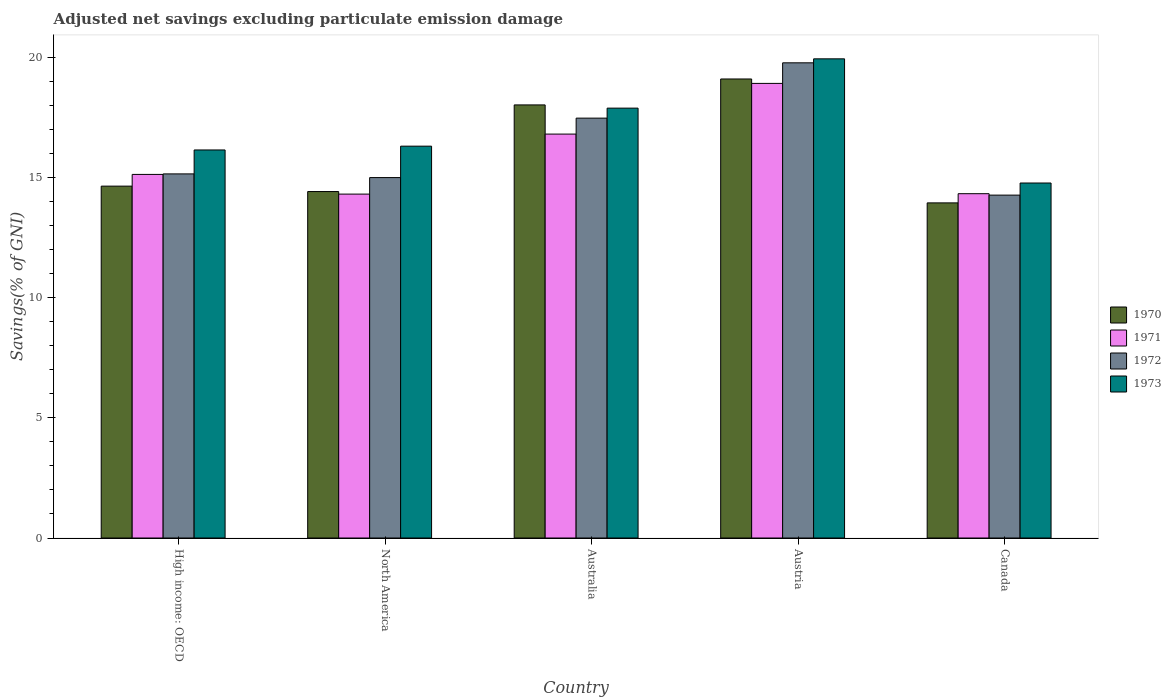Are the number of bars on each tick of the X-axis equal?
Your answer should be very brief. Yes. How many bars are there on the 1st tick from the right?
Keep it short and to the point. 4. What is the adjusted net savings in 1972 in North America?
Provide a short and direct response. 15. Across all countries, what is the maximum adjusted net savings in 1971?
Your answer should be compact. 18.92. Across all countries, what is the minimum adjusted net savings in 1970?
Offer a terse response. 13.95. In which country was the adjusted net savings in 1972 minimum?
Ensure brevity in your answer.  Canada. What is the total adjusted net savings in 1971 in the graph?
Your answer should be very brief. 79.51. What is the difference between the adjusted net savings in 1970 in Canada and that in High income: OECD?
Offer a terse response. -0.7. What is the difference between the adjusted net savings in 1973 in Canada and the adjusted net savings in 1972 in North America?
Make the answer very short. -0.23. What is the average adjusted net savings in 1970 per country?
Your answer should be compact. 16.03. What is the difference between the adjusted net savings of/in 1970 and adjusted net savings of/in 1972 in Australia?
Your answer should be very brief. 0.55. What is the ratio of the adjusted net savings in 1973 in High income: OECD to that in North America?
Give a very brief answer. 0.99. What is the difference between the highest and the second highest adjusted net savings in 1970?
Provide a short and direct response. -1.08. What is the difference between the highest and the lowest adjusted net savings in 1971?
Provide a succinct answer. 4.61. Is the sum of the adjusted net savings in 1972 in Austria and North America greater than the maximum adjusted net savings in 1971 across all countries?
Ensure brevity in your answer.  Yes. What does the 4th bar from the right in High income: OECD represents?
Offer a terse response. 1970. How many countries are there in the graph?
Ensure brevity in your answer.  5. Does the graph contain any zero values?
Offer a terse response. No. How many legend labels are there?
Make the answer very short. 4. How are the legend labels stacked?
Provide a short and direct response. Vertical. What is the title of the graph?
Your answer should be compact. Adjusted net savings excluding particulate emission damage. What is the label or title of the Y-axis?
Keep it short and to the point. Savings(% of GNI). What is the Savings(% of GNI) in 1970 in High income: OECD?
Offer a very short reply. 14.65. What is the Savings(% of GNI) of 1971 in High income: OECD?
Keep it short and to the point. 15.13. What is the Savings(% of GNI) in 1972 in High income: OECD?
Keep it short and to the point. 15.15. What is the Savings(% of GNI) in 1973 in High income: OECD?
Keep it short and to the point. 16.15. What is the Savings(% of GNI) in 1970 in North America?
Ensure brevity in your answer.  14.42. What is the Savings(% of GNI) in 1971 in North America?
Give a very brief answer. 14.31. What is the Savings(% of GNI) of 1972 in North America?
Make the answer very short. 15. What is the Savings(% of GNI) in 1973 in North America?
Your answer should be very brief. 16.31. What is the Savings(% of GNI) of 1970 in Australia?
Provide a succinct answer. 18.03. What is the Savings(% of GNI) in 1971 in Australia?
Give a very brief answer. 16.81. What is the Savings(% of GNI) of 1972 in Australia?
Offer a very short reply. 17.48. What is the Savings(% of GNI) of 1973 in Australia?
Your answer should be very brief. 17.89. What is the Savings(% of GNI) of 1970 in Austria?
Provide a succinct answer. 19.11. What is the Savings(% of GNI) of 1971 in Austria?
Your answer should be very brief. 18.92. What is the Savings(% of GNI) in 1972 in Austria?
Provide a succinct answer. 19.78. What is the Savings(% of GNI) in 1973 in Austria?
Ensure brevity in your answer.  19.94. What is the Savings(% of GNI) in 1970 in Canada?
Offer a very short reply. 13.95. What is the Savings(% of GNI) of 1971 in Canada?
Your answer should be very brief. 14.33. What is the Savings(% of GNI) in 1972 in Canada?
Ensure brevity in your answer.  14.27. What is the Savings(% of GNI) of 1973 in Canada?
Provide a short and direct response. 14.78. Across all countries, what is the maximum Savings(% of GNI) of 1970?
Keep it short and to the point. 19.11. Across all countries, what is the maximum Savings(% of GNI) of 1971?
Give a very brief answer. 18.92. Across all countries, what is the maximum Savings(% of GNI) in 1972?
Provide a short and direct response. 19.78. Across all countries, what is the maximum Savings(% of GNI) of 1973?
Provide a succinct answer. 19.94. Across all countries, what is the minimum Savings(% of GNI) in 1970?
Provide a succinct answer. 13.95. Across all countries, what is the minimum Savings(% of GNI) of 1971?
Your answer should be compact. 14.31. Across all countries, what is the minimum Savings(% of GNI) in 1972?
Make the answer very short. 14.27. Across all countries, what is the minimum Savings(% of GNI) in 1973?
Your answer should be very brief. 14.78. What is the total Savings(% of GNI) in 1970 in the graph?
Offer a very short reply. 80.15. What is the total Savings(% of GNI) in 1971 in the graph?
Offer a terse response. 79.51. What is the total Savings(% of GNI) of 1972 in the graph?
Provide a short and direct response. 81.68. What is the total Savings(% of GNI) of 1973 in the graph?
Provide a succinct answer. 85.07. What is the difference between the Savings(% of GNI) in 1970 in High income: OECD and that in North America?
Provide a succinct answer. 0.23. What is the difference between the Savings(% of GNI) of 1971 in High income: OECD and that in North America?
Your answer should be compact. 0.82. What is the difference between the Savings(% of GNI) of 1972 in High income: OECD and that in North America?
Make the answer very short. 0.15. What is the difference between the Savings(% of GNI) of 1973 in High income: OECD and that in North America?
Offer a very short reply. -0.16. What is the difference between the Savings(% of GNI) of 1970 in High income: OECD and that in Australia?
Offer a very short reply. -3.38. What is the difference between the Savings(% of GNI) in 1971 in High income: OECD and that in Australia?
Your answer should be very brief. -1.68. What is the difference between the Savings(% of GNI) of 1972 in High income: OECD and that in Australia?
Offer a terse response. -2.32. What is the difference between the Savings(% of GNI) in 1973 in High income: OECD and that in Australia?
Offer a very short reply. -1.74. What is the difference between the Savings(% of GNI) in 1970 in High income: OECD and that in Austria?
Give a very brief answer. -4.46. What is the difference between the Savings(% of GNI) in 1971 in High income: OECD and that in Austria?
Provide a succinct answer. -3.79. What is the difference between the Savings(% of GNI) of 1972 in High income: OECD and that in Austria?
Provide a short and direct response. -4.62. What is the difference between the Savings(% of GNI) in 1973 in High income: OECD and that in Austria?
Your response must be concise. -3.79. What is the difference between the Savings(% of GNI) in 1970 in High income: OECD and that in Canada?
Offer a very short reply. 0.7. What is the difference between the Savings(% of GNI) of 1971 in High income: OECD and that in Canada?
Offer a very short reply. 0.8. What is the difference between the Savings(% of GNI) of 1972 in High income: OECD and that in Canada?
Your response must be concise. 0.88. What is the difference between the Savings(% of GNI) in 1973 in High income: OECD and that in Canada?
Give a very brief answer. 1.38. What is the difference between the Savings(% of GNI) of 1970 in North America and that in Australia?
Ensure brevity in your answer.  -3.61. What is the difference between the Savings(% of GNI) of 1971 in North America and that in Australia?
Provide a succinct answer. -2.5. What is the difference between the Savings(% of GNI) of 1972 in North America and that in Australia?
Your answer should be very brief. -2.47. What is the difference between the Savings(% of GNI) of 1973 in North America and that in Australia?
Ensure brevity in your answer.  -1.58. What is the difference between the Savings(% of GNI) of 1970 in North America and that in Austria?
Provide a short and direct response. -4.69. What is the difference between the Savings(% of GNI) in 1971 in North America and that in Austria?
Provide a short and direct response. -4.61. What is the difference between the Savings(% of GNI) of 1972 in North America and that in Austria?
Make the answer very short. -4.78. What is the difference between the Savings(% of GNI) in 1973 in North America and that in Austria?
Your response must be concise. -3.63. What is the difference between the Savings(% of GNI) in 1970 in North America and that in Canada?
Make the answer very short. 0.47. What is the difference between the Savings(% of GNI) of 1971 in North America and that in Canada?
Ensure brevity in your answer.  -0.02. What is the difference between the Savings(% of GNI) of 1972 in North America and that in Canada?
Provide a short and direct response. 0.73. What is the difference between the Savings(% of GNI) of 1973 in North America and that in Canada?
Give a very brief answer. 1.53. What is the difference between the Savings(% of GNI) in 1970 in Australia and that in Austria?
Ensure brevity in your answer.  -1.08. What is the difference between the Savings(% of GNI) of 1971 in Australia and that in Austria?
Provide a succinct answer. -2.11. What is the difference between the Savings(% of GNI) of 1972 in Australia and that in Austria?
Ensure brevity in your answer.  -2.3. What is the difference between the Savings(% of GNI) in 1973 in Australia and that in Austria?
Your answer should be very brief. -2.05. What is the difference between the Savings(% of GNI) of 1970 in Australia and that in Canada?
Offer a very short reply. 4.08. What is the difference between the Savings(% of GNI) of 1971 in Australia and that in Canada?
Give a very brief answer. 2.48. What is the difference between the Savings(% of GNI) in 1972 in Australia and that in Canada?
Give a very brief answer. 3.2. What is the difference between the Savings(% of GNI) of 1973 in Australia and that in Canada?
Make the answer very short. 3.12. What is the difference between the Savings(% of GNI) of 1970 in Austria and that in Canada?
Offer a very short reply. 5.16. What is the difference between the Savings(% of GNI) in 1971 in Austria and that in Canada?
Your answer should be compact. 4.59. What is the difference between the Savings(% of GNI) in 1972 in Austria and that in Canada?
Give a very brief answer. 5.51. What is the difference between the Savings(% of GNI) in 1973 in Austria and that in Canada?
Your answer should be compact. 5.17. What is the difference between the Savings(% of GNI) in 1970 in High income: OECD and the Savings(% of GNI) in 1971 in North America?
Your answer should be very brief. 0.33. What is the difference between the Savings(% of GNI) in 1970 in High income: OECD and the Savings(% of GNI) in 1972 in North America?
Offer a very short reply. -0.36. What is the difference between the Savings(% of GNI) in 1970 in High income: OECD and the Savings(% of GNI) in 1973 in North America?
Provide a succinct answer. -1.66. What is the difference between the Savings(% of GNI) in 1971 in High income: OECD and the Savings(% of GNI) in 1972 in North America?
Your answer should be very brief. 0.13. What is the difference between the Savings(% of GNI) in 1971 in High income: OECD and the Savings(% of GNI) in 1973 in North America?
Your answer should be very brief. -1.18. What is the difference between the Savings(% of GNI) in 1972 in High income: OECD and the Savings(% of GNI) in 1973 in North America?
Your answer should be compact. -1.15. What is the difference between the Savings(% of GNI) in 1970 in High income: OECD and the Savings(% of GNI) in 1971 in Australia?
Offer a terse response. -2.17. What is the difference between the Savings(% of GNI) of 1970 in High income: OECD and the Savings(% of GNI) of 1972 in Australia?
Offer a very short reply. -2.83. What is the difference between the Savings(% of GNI) in 1970 in High income: OECD and the Savings(% of GNI) in 1973 in Australia?
Ensure brevity in your answer.  -3.25. What is the difference between the Savings(% of GNI) of 1971 in High income: OECD and the Savings(% of GNI) of 1972 in Australia?
Offer a very short reply. -2.34. What is the difference between the Savings(% of GNI) of 1971 in High income: OECD and the Savings(% of GNI) of 1973 in Australia?
Offer a terse response. -2.76. What is the difference between the Savings(% of GNI) in 1972 in High income: OECD and the Savings(% of GNI) in 1973 in Australia?
Your answer should be compact. -2.74. What is the difference between the Savings(% of GNI) in 1970 in High income: OECD and the Savings(% of GNI) in 1971 in Austria?
Make the answer very short. -4.28. What is the difference between the Savings(% of GNI) of 1970 in High income: OECD and the Savings(% of GNI) of 1972 in Austria?
Your response must be concise. -5.13. What is the difference between the Savings(% of GNI) in 1970 in High income: OECD and the Savings(% of GNI) in 1973 in Austria?
Your answer should be very brief. -5.3. What is the difference between the Savings(% of GNI) in 1971 in High income: OECD and the Savings(% of GNI) in 1972 in Austria?
Your answer should be compact. -4.64. What is the difference between the Savings(% of GNI) of 1971 in High income: OECD and the Savings(% of GNI) of 1973 in Austria?
Ensure brevity in your answer.  -4.81. What is the difference between the Savings(% of GNI) in 1972 in High income: OECD and the Savings(% of GNI) in 1973 in Austria?
Give a very brief answer. -4.79. What is the difference between the Savings(% of GNI) of 1970 in High income: OECD and the Savings(% of GNI) of 1971 in Canada?
Your answer should be very brief. 0.32. What is the difference between the Savings(% of GNI) in 1970 in High income: OECD and the Savings(% of GNI) in 1972 in Canada?
Keep it short and to the point. 0.37. What is the difference between the Savings(% of GNI) in 1970 in High income: OECD and the Savings(% of GNI) in 1973 in Canada?
Offer a terse response. -0.13. What is the difference between the Savings(% of GNI) in 1971 in High income: OECD and the Savings(% of GNI) in 1972 in Canada?
Ensure brevity in your answer.  0.86. What is the difference between the Savings(% of GNI) of 1971 in High income: OECD and the Savings(% of GNI) of 1973 in Canada?
Make the answer very short. 0.36. What is the difference between the Savings(% of GNI) in 1972 in High income: OECD and the Savings(% of GNI) in 1973 in Canada?
Provide a succinct answer. 0.38. What is the difference between the Savings(% of GNI) of 1970 in North America and the Savings(% of GNI) of 1971 in Australia?
Give a very brief answer. -2.39. What is the difference between the Savings(% of GNI) of 1970 in North America and the Savings(% of GNI) of 1972 in Australia?
Your answer should be very brief. -3.06. What is the difference between the Savings(% of GNI) of 1970 in North America and the Savings(% of GNI) of 1973 in Australia?
Keep it short and to the point. -3.47. What is the difference between the Savings(% of GNI) in 1971 in North America and the Savings(% of GNI) in 1972 in Australia?
Offer a terse response. -3.16. What is the difference between the Savings(% of GNI) in 1971 in North America and the Savings(% of GNI) in 1973 in Australia?
Provide a short and direct response. -3.58. What is the difference between the Savings(% of GNI) in 1972 in North America and the Savings(% of GNI) in 1973 in Australia?
Your response must be concise. -2.89. What is the difference between the Savings(% of GNI) of 1970 in North America and the Savings(% of GNI) of 1971 in Austria?
Make the answer very short. -4.5. What is the difference between the Savings(% of GNI) of 1970 in North America and the Savings(% of GNI) of 1972 in Austria?
Make the answer very short. -5.36. What is the difference between the Savings(% of GNI) in 1970 in North America and the Savings(% of GNI) in 1973 in Austria?
Offer a very short reply. -5.52. What is the difference between the Savings(% of GNI) of 1971 in North America and the Savings(% of GNI) of 1972 in Austria?
Make the answer very short. -5.46. What is the difference between the Savings(% of GNI) of 1971 in North America and the Savings(% of GNI) of 1973 in Austria?
Ensure brevity in your answer.  -5.63. What is the difference between the Savings(% of GNI) in 1972 in North America and the Savings(% of GNI) in 1973 in Austria?
Make the answer very short. -4.94. What is the difference between the Savings(% of GNI) in 1970 in North America and the Savings(% of GNI) in 1971 in Canada?
Offer a terse response. 0.09. What is the difference between the Savings(% of GNI) in 1970 in North America and the Savings(% of GNI) in 1972 in Canada?
Your answer should be compact. 0.15. What is the difference between the Savings(% of GNI) in 1970 in North America and the Savings(% of GNI) in 1973 in Canada?
Your answer should be compact. -0.36. What is the difference between the Savings(% of GNI) in 1971 in North America and the Savings(% of GNI) in 1972 in Canada?
Your response must be concise. 0.04. What is the difference between the Savings(% of GNI) of 1971 in North America and the Savings(% of GNI) of 1973 in Canada?
Offer a very short reply. -0.46. What is the difference between the Savings(% of GNI) in 1972 in North America and the Savings(% of GNI) in 1973 in Canada?
Provide a short and direct response. 0.23. What is the difference between the Savings(% of GNI) in 1970 in Australia and the Savings(% of GNI) in 1971 in Austria?
Offer a very short reply. -0.9. What is the difference between the Savings(% of GNI) of 1970 in Australia and the Savings(% of GNI) of 1972 in Austria?
Make the answer very short. -1.75. What is the difference between the Savings(% of GNI) of 1970 in Australia and the Savings(% of GNI) of 1973 in Austria?
Your answer should be very brief. -1.92. What is the difference between the Savings(% of GNI) of 1971 in Australia and the Savings(% of GNI) of 1972 in Austria?
Offer a terse response. -2.97. What is the difference between the Savings(% of GNI) of 1971 in Australia and the Savings(% of GNI) of 1973 in Austria?
Make the answer very short. -3.13. What is the difference between the Savings(% of GNI) of 1972 in Australia and the Savings(% of GNI) of 1973 in Austria?
Make the answer very short. -2.47. What is the difference between the Savings(% of GNI) of 1970 in Australia and the Savings(% of GNI) of 1971 in Canada?
Your response must be concise. 3.7. What is the difference between the Savings(% of GNI) of 1970 in Australia and the Savings(% of GNI) of 1972 in Canada?
Keep it short and to the point. 3.75. What is the difference between the Savings(% of GNI) of 1970 in Australia and the Savings(% of GNI) of 1973 in Canada?
Keep it short and to the point. 3.25. What is the difference between the Savings(% of GNI) in 1971 in Australia and the Savings(% of GNI) in 1972 in Canada?
Provide a succinct answer. 2.54. What is the difference between the Savings(% of GNI) of 1971 in Australia and the Savings(% of GNI) of 1973 in Canada?
Keep it short and to the point. 2.04. What is the difference between the Savings(% of GNI) of 1970 in Austria and the Savings(% of GNI) of 1971 in Canada?
Keep it short and to the point. 4.77. What is the difference between the Savings(% of GNI) of 1970 in Austria and the Savings(% of GNI) of 1972 in Canada?
Make the answer very short. 4.83. What is the difference between the Savings(% of GNI) in 1970 in Austria and the Savings(% of GNI) in 1973 in Canada?
Your answer should be very brief. 4.33. What is the difference between the Savings(% of GNI) in 1971 in Austria and the Savings(% of GNI) in 1972 in Canada?
Provide a succinct answer. 4.65. What is the difference between the Savings(% of GNI) in 1971 in Austria and the Savings(% of GNI) in 1973 in Canada?
Offer a terse response. 4.15. What is the difference between the Savings(% of GNI) of 1972 in Austria and the Savings(% of GNI) of 1973 in Canada?
Make the answer very short. 5. What is the average Savings(% of GNI) of 1970 per country?
Offer a terse response. 16.03. What is the average Savings(% of GNI) of 1971 per country?
Ensure brevity in your answer.  15.9. What is the average Savings(% of GNI) of 1972 per country?
Offer a very short reply. 16.34. What is the average Savings(% of GNI) in 1973 per country?
Your answer should be compact. 17.01. What is the difference between the Savings(% of GNI) of 1970 and Savings(% of GNI) of 1971 in High income: OECD?
Offer a terse response. -0.49. What is the difference between the Savings(% of GNI) of 1970 and Savings(% of GNI) of 1972 in High income: OECD?
Your answer should be compact. -0.51. What is the difference between the Savings(% of GNI) in 1970 and Savings(% of GNI) in 1973 in High income: OECD?
Provide a short and direct response. -1.51. What is the difference between the Savings(% of GNI) in 1971 and Savings(% of GNI) in 1972 in High income: OECD?
Ensure brevity in your answer.  -0.02. What is the difference between the Savings(% of GNI) in 1971 and Savings(% of GNI) in 1973 in High income: OECD?
Make the answer very short. -1.02. What is the difference between the Savings(% of GNI) in 1972 and Savings(% of GNI) in 1973 in High income: OECD?
Provide a succinct answer. -1. What is the difference between the Savings(% of GNI) of 1970 and Savings(% of GNI) of 1971 in North America?
Your answer should be compact. 0.11. What is the difference between the Savings(% of GNI) of 1970 and Savings(% of GNI) of 1972 in North America?
Keep it short and to the point. -0.58. What is the difference between the Savings(% of GNI) of 1970 and Savings(% of GNI) of 1973 in North America?
Your response must be concise. -1.89. What is the difference between the Savings(% of GNI) in 1971 and Savings(% of GNI) in 1972 in North America?
Give a very brief answer. -0.69. What is the difference between the Savings(% of GNI) in 1971 and Savings(% of GNI) in 1973 in North America?
Provide a succinct answer. -2. What is the difference between the Savings(% of GNI) in 1972 and Savings(% of GNI) in 1973 in North America?
Your answer should be compact. -1.31. What is the difference between the Savings(% of GNI) of 1970 and Savings(% of GNI) of 1971 in Australia?
Give a very brief answer. 1.21. What is the difference between the Savings(% of GNI) of 1970 and Savings(% of GNI) of 1972 in Australia?
Your response must be concise. 0.55. What is the difference between the Savings(% of GNI) of 1970 and Savings(% of GNI) of 1973 in Australia?
Offer a terse response. 0.13. What is the difference between the Savings(% of GNI) of 1971 and Savings(% of GNI) of 1972 in Australia?
Provide a succinct answer. -0.66. What is the difference between the Savings(% of GNI) in 1971 and Savings(% of GNI) in 1973 in Australia?
Your answer should be compact. -1.08. What is the difference between the Savings(% of GNI) in 1972 and Savings(% of GNI) in 1973 in Australia?
Your answer should be very brief. -0.42. What is the difference between the Savings(% of GNI) in 1970 and Savings(% of GNI) in 1971 in Austria?
Give a very brief answer. 0.18. What is the difference between the Savings(% of GNI) of 1970 and Savings(% of GNI) of 1972 in Austria?
Give a very brief answer. -0.67. What is the difference between the Savings(% of GNI) of 1970 and Savings(% of GNI) of 1973 in Austria?
Provide a short and direct response. -0.84. What is the difference between the Savings(% of GNI) of 1971 and Savings(% of GNI) of 1972 in Austria?
Your answer should be very brief. -0.86. What is the difference between the Savings(% of GNI) in 1971 and Savings(% of GNI) in 1973 in Austria?
Provide a short and direct response. -1.02. What is the difference between the Savings(% of GNI) of 1972 and Savings(% of GNI) of 1973 in Austria?
Provide a succinct answer. -0.17. What is the difference between the Savings(% of GNI) of 1970 and Savings(% of GNI) of 1971 in Canada?
Your answer should be compact. -0.38. What is the difference between the Savings(% of GNI) of 1970 and Savings(% of GNI) of 1972 in Canada?
Offer a terse response. -0.32. What is the difference between the Savings(% of GNI) in 1970 and Savings(% of GNI) in 1973 in Canada?
Offer a very short reply. -0.83. What is the difference between the Savings(% of GNI) in 1971 and Savings(% of GNI) in 1972 in Canada?
Your response must be concise. 0.06. What is the difference between the Savings(% of GNI) in 1971 and Savings(% of GNI) in 1973 in Canada?
Make the answer very short. -0.45. What is the difference between the Savings(% of GNI) in 1972 and Savings(% of GNI) in 1973 in Canada?
Your answer should be compact. -0.5. What is the ratio of the Savings(% of GNI) in 1970 in High income: OECD to that in North America?
Offer a very short reply. 1.02. What is the ratio of the Savings(% of GNI) of 1971 in High income: OECD to that in North America?
Provide a short and direct response. 1.06. What is the ratio of the Savings(% of GNI) in 1972 in High income: OECD to that in North America?
Your answer should be compact. 1.01. What is the ratio of the Savings(% of GNI) in 1973 in High income: OECD to that in North America?
Provide a succinct answer. 0.99. What is the ratio of the Savings(% of GNI) of 1970 in High income: OECD to that in Australia?
Offer a very short reply. 0.81. What is the ratio of the Savings(% of GNI) of 1971 in High income: OECD to that in Australia?
Offer a terse response. 0.9. What is the ratio of the Savings(% of GNI) of 1972 in High income: OECD to that in Australia?
Provide a succinct answer. 0.87. What is the ratio of the Savings(% of GNI) in 1973 in High income: OECD to that in Australia?
Keep it short and to the point. 0.9. What is the ratio of the Savings(% of GNI) in 1970 in High income: OECD to that in Austria?
Your answer should be very brief. 0.77. What is the ratio of the Savings(% of GNI) of 1971 in High income: OECD to that in Austria?
Provide a succinct answer. 0.8. What is the ratio of the Savings(% of GNI) in 1972 in High income: OECD to that in Austria?
Ensure brevity in your answer.  0.77. What is the ratio of the Savings(% of GNI) in 1973 in High income: OECD to that in Austria?
Keep it short and to the point. 0.81. What is the ratio of the Savings(% of GNI) of 1970 in High income: OECD to that in Canada?
Keep it short and to the point. 1.05. What is the ratio of the Savings(% of GNI) of 1971 in High income: OECD to that in Canada?
Provide a succinct answer. 1.06. What is the ratio of the Savings(% of GNI) of 1972 in High income: OECD to that in Canada?
Provide a short and direct response. 1.06. What is the ratio of the Savings(% of GNI) in 1973 in High income: OECD to that in Canada?
Your answer should be compact. 1.09. What is the ratio of the Savings(% of GNI) in 1970 in North America to that in Australia?
Ensure brevity in your answer.  0.8. What is the ratio of the Savings(% of GNI) of 1971 in North America to that in Australia?
Make the answer very short. 0.85. What is the ratio of the Savings(% of GNI) of 1972 in North America to that in Australia?
Offer a very short reply. 0.86. What is the ratio of the Savings(% of GNI) of 1973 in North America to that in Australia?
Provide a succinct answer. 0.91. What is the ratio of the Savings(% of GNI) in 1970 in North America to that in Austria?
Give a very brief answer. 0.75. What is the ratio of the Savings(% of GNI) in 1971 in North America to that in Austria?
Keep it short and to the point. 0.76. What is the ratio of the Savings(% of GNI) in 1972 in North America to that in Austria?
Provide a succinct answer. 0.76. What is the ratio of the Savings(% of GNI) in 1973 in North America to that in Austria?
Provide a succinct answer. 0.82. What is the ratio of the Savings(% of GNI) in 1970 in North America to that in Canada?
Give a very brief answer. 1.03. What is the ratio of the Savings(% of GNI) in 1971 in North America to that in Canada?
Keep it short and to the point. 1. What is the ratio of the Savings(% of GNI) of 1972 in North America to that in Canada?
Offer a terse response. 1.05. What is the ratio of the Savings(% of GNI) of 1973 in North America to that in Canada?
Ensure brevity in your answer.  1.1. What is the ratio of the Savings(% of GNI) of 1970 in Australia to that in Austria?
Keep it short and to the point. 0.94. What is the ratio of the Savings(% of GNI) of 1971 in Australia to that in Austria?
Make the answer very short. 0.89. What is the ratio of the Savings(% of GNI) of 1972 in Australia to that in Austria?
Offer a very short reply. 0.88. What is the ratio of the Savings(% of GNI) in 1973 in Australia to that in Austria?
Offer a very short reply. 0.9. What is the ratio of the Savings(% of GNI) of 1970 in Australia to that in Canada?
Ensure brevity in your answer.  1.29. What is the ratio of the Savings(% of GNI) of 1971 in Australia to that in Canada?
Keep it short and to the point. 1.17. What is the ratio of the Savings(% of GNI) in 1972 in Australia to that in Canada?
Provide a succinct answer. 1.22. What is the ratio of the Savings(% of GNI) in 1973 in Australia to that in Canada?
Your answer should be very brief. 1.21. What is the ratio of the Savings(% of GNI) of 1970 in Austria to that in Canada?
Your answer should be compact. 1.37. What is the ratio of the Savings(% of GNI) of 1971 in Austria to that in Canada?
Give a very brief answer. 1.32. What is the ratio of the Savings(% of GNI) of 1972 in Austria to that in Canada?
Offer a terse response. 1.39. What is the ratio of the Savings(% of GNI) in 1973 in Austria to that in Canada?
Offer a terse response. 1.35. What is the difference between the highest and the second highest Savings(% of GNI) in 1970?
Provide a short and direct response. 1.08. What is the difference between the highest and the second highest Savings(% of GNI) of 1971?
Keep it short and to the point. 2.11. What is the difference between the highest and the second highest Savings(% of GNI) of 1972?
Your answer should be very brief. 2.3. What is the difference between the highest and the second highest Savings(% of GNI) in 1973?
Give a very brief answer. 2.05. What is the difference between the highest and the lowest Savings(% of GNI) of 1970?
Provide a short and direct response. 5.16. What is the difference between the highest and the lowest Savings(% of GNI) in 1971?
Your response must be concise. 4.61. What is the difference between the highest and the lowest Savings(% of GNI) of 1972?
Keep it short and to the point. 5.51. What is the difference between the highest and the lowest Savings(% of GNI) in 1973?
Make the answer very short. 5.17. 